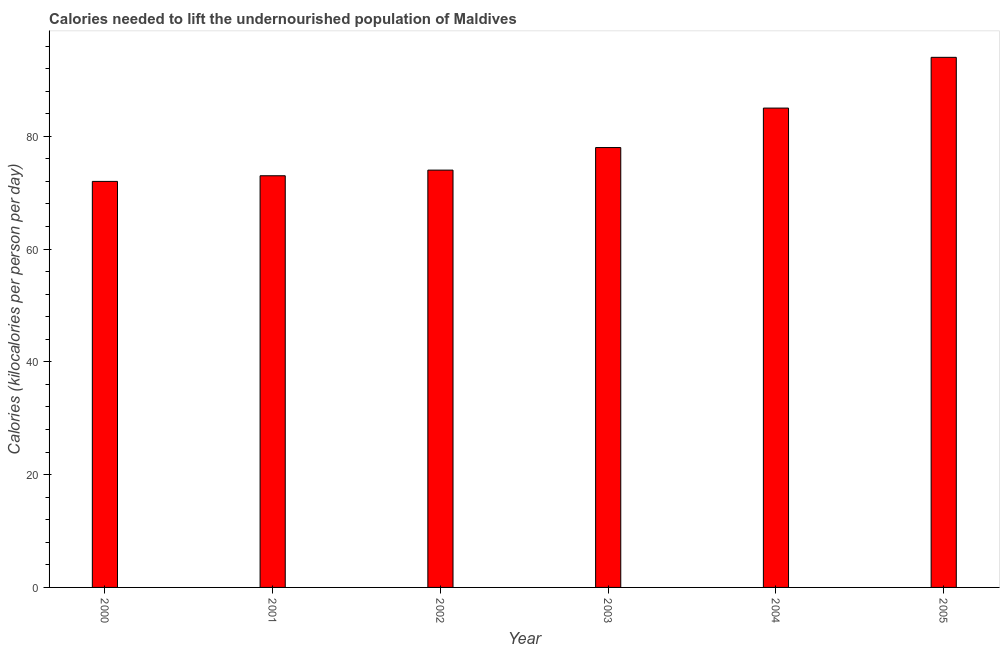Does the graph contain any zero values?
Offer a very short reply. No. What is the title of the graph?
Your response must be concise. Calories needed to lift the undernourished population of Maldives. What is the label or title of the Y-axis?
Make the answer very short. Calories (kilocalories per person per day). Across all years, what is the maximum depth of food deficit?
Provide a short and direct response. 94. In which year was the depth of food deficit maximum?
Provide a succinct answer. 2005. What is the sum of the depth of food deficit?
Your response must be concise. 476. What is the average depth of food deficit per year?
Provide a succinct answer. 79. In how many years, is the depth of food deficit greater than 92 kilocalories?
Offer a terse response. 1. Do a majority of the years between 2000 and 2004 (inclusive) have depth of food deficit greater than 56 kilocalories?
Your answer should be very brief. Yes. What is the ratio of the depth of food deficit in 2004 to that in 2005?
Ensure brevity in your answer.  0.9. Is the depth of food deficit in 2002 less than that in 2004?
Provide a short and direct response. Yes. What is the difference between the highest and the second highest depth of food deficit?
Offer a very short reply. 9. Is the sum of the depth of food deficit in 2001 and 2004 greater than the maximum depth of food deficit across all years?
Offer a very short reply. Yes. How many years are there in the graph?
Make the answer very short. 6. What is the difference between two consecutive major ticks on the Y-axis?
Offer a very short reply. 20. What is the Calories (kilocalories per person per day) of 2003?
Keep it short and to the point. 78. What is the Calories (kilocalories per person per day) in 2004?
Your answer should be very brief. 85. What is the Calories (kilocalories per person per day) in 2005?
Your response must be concise. 94. What is the difference between the Calories (kilocalories per person per day) in 2000 and 2001?
Keep it short and to the point. -1. What is the difference between the Calories (kilocalories per person per day) in 2000 and 2002?
Offer a terse response. -2. What is the difference between the Calories (kilocalories per person per day) in 2000 and 2004?
Provide a short and direct response. -13. What is the difference between the Calories (kilocalories per person per day) in 2001 and 2003?
Provide a succinct answer. -5. What is the difference between the Calories (kilocalories per person per day) in 2002 and 2003?
Give a very brief answer. -4. What is the difference between the Calories (kilocalories per person per day) in 2003 and 2005?
Provide a short and direct response. -16. What is the ratio of the Calories (kilocalories per person per day) in 2000 to that in 2003?
Your response must be concise. 0.92. What is the ratio of the Calories (kilocalories per person per day) in 2000 to that in 2004?
Provide a succinct answer. 0.85. What is the ratio of the Calories (kilocalories per person per day) in 2000 to that in 2005?
Your response must be concise. 0.77. What is the ratio of the Calories (kilocalories per person per day) in 2001 to that in 2003?
Offer a terse response. 0.94. What is the ratio of the Calories (kilocalories per person per day) in 2001 to that in 2004?
Provide a short and direct response. 0.86. What is the ratio of the Calories (kilocalories per person per day) in 2001 to that in 2005?
Ensure brevity in your answer.  0.78. What is the ratio of the Calories (kilocalories per person per day) in 2002 to that in 2003?
Ensure brevity in your answer.  0.95. What is the ratio of the Calories (kilocalories per person per day) in 2002 to that in 2004?
Provide a succinct answer. 0.87. What is the ratio of the Calories (kilocalories per person per day) in 2002 to that in 2005?
Make the answer very short. 0.79. What is the ratio of the Calories (kilocalories per person per day) in 2003 to that in 2004?
Keep it short and to the point. 0.92. What is the ratio of the Calories (kilocalories per person per day) in 2003 to that in 2005?
Offer a terse response. 0.83. What is the ratio of the Calories (kilocalories per person per day) in 2004 to that in 2005?
Your answer should be very brief. 0.9. 